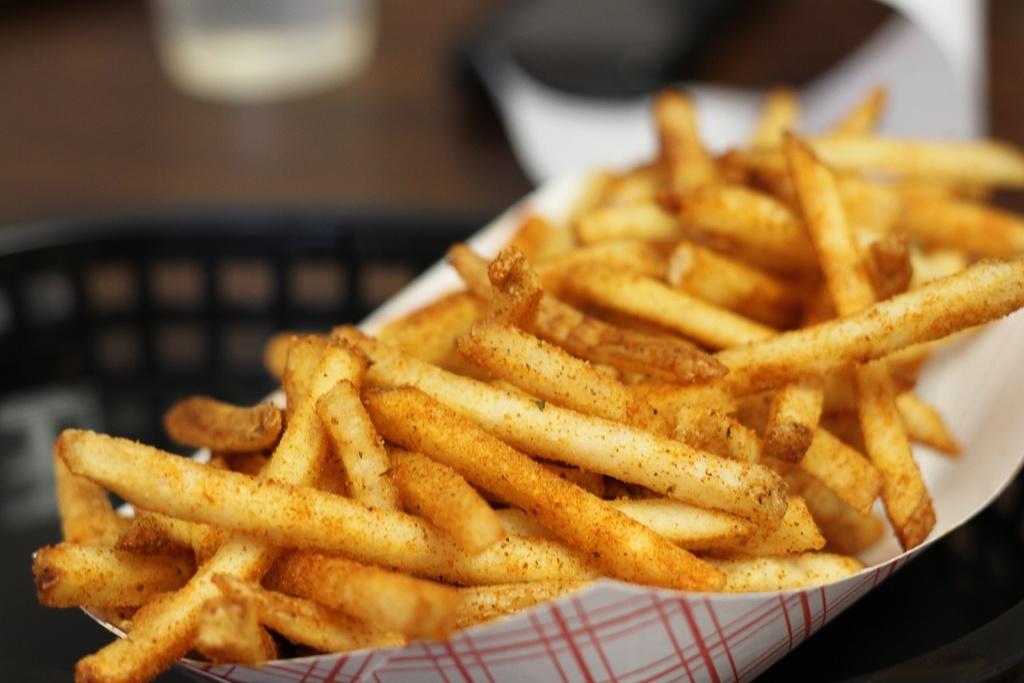Can you describe this image briefly? In this picture we can see french fries in a paper plate. In the background of the image it is blurry. 